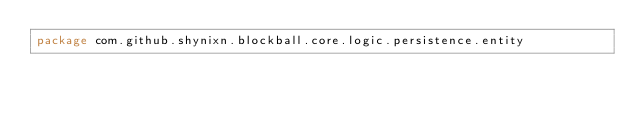<code> <loc_0><loc_0><loc_500><loc_500><_Kotlin_>package com.github.shynixn.blockball.core.logic.persistence.entity
</code> 